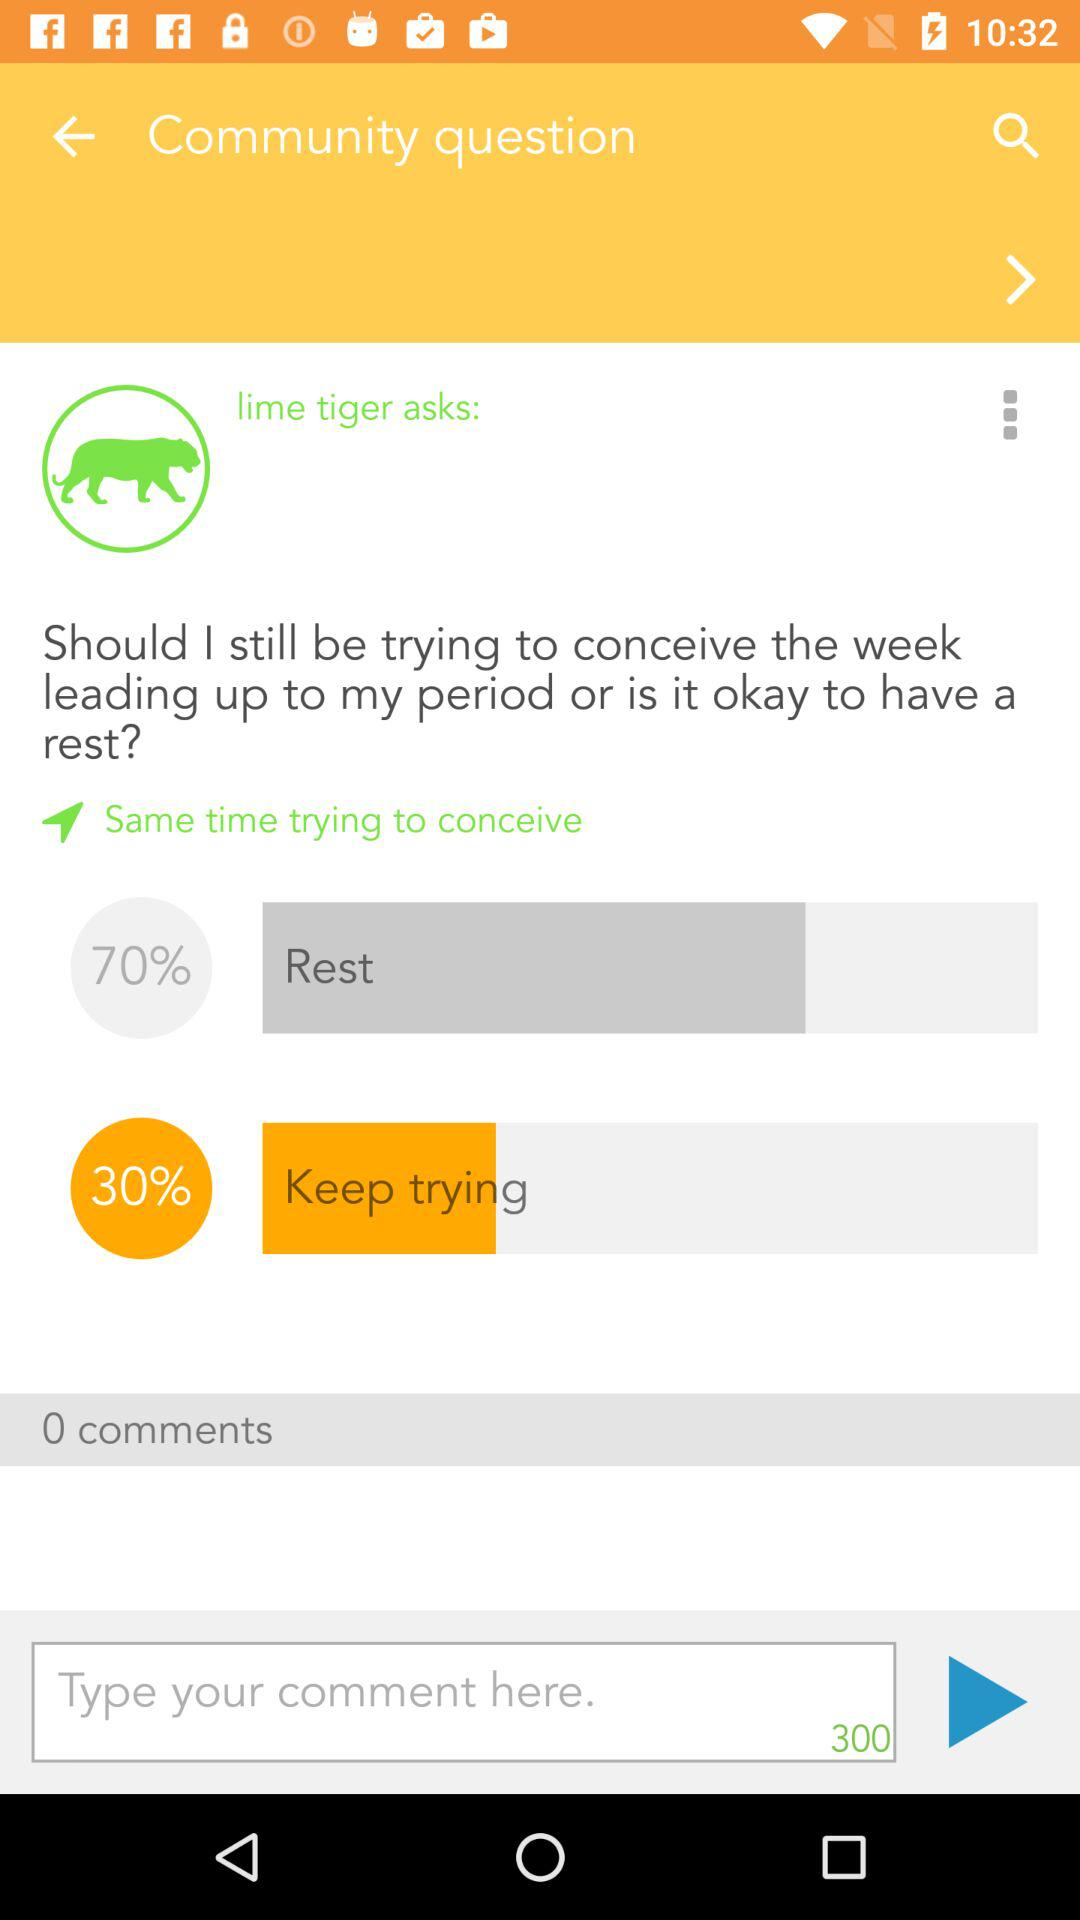What is the "Keep trying" percentage? The "Keep trying" percentage is 30%. 